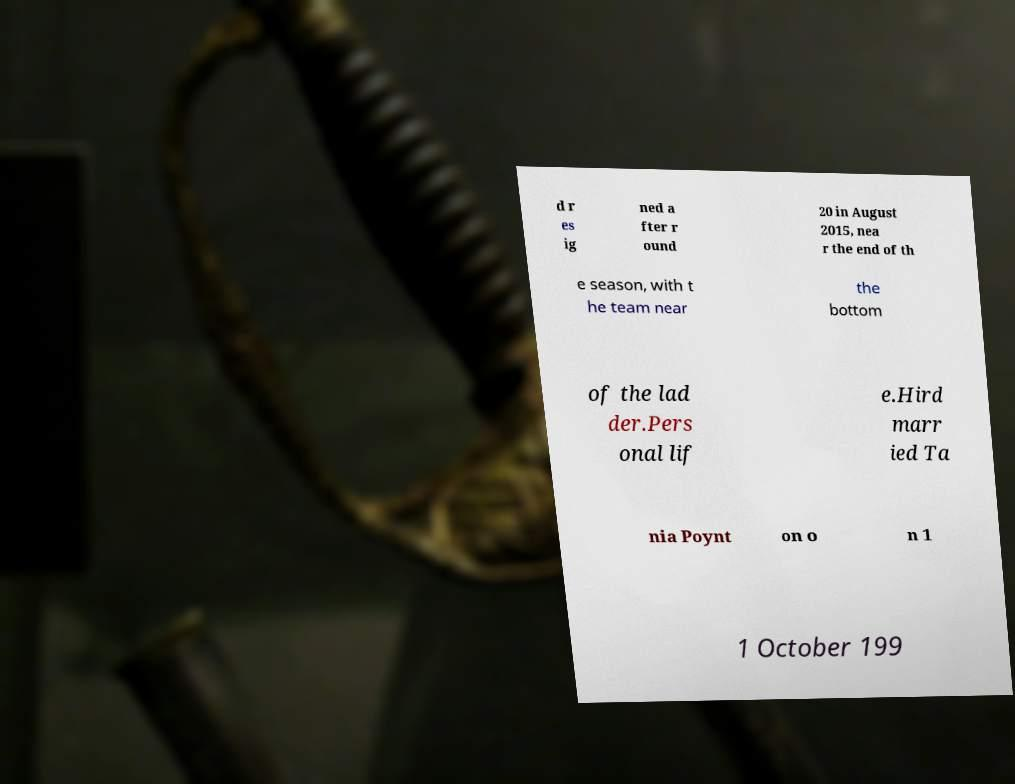Please read and relay the text visible in this image. What does it say? d r es ig ned a fter r ound 20 in August 2015, nea r the end of th e season, with t he team near the bottom of the lad der.Pers onal lif e.Hird marr ied Ta nia Poynt on o n 1 1 October 199 